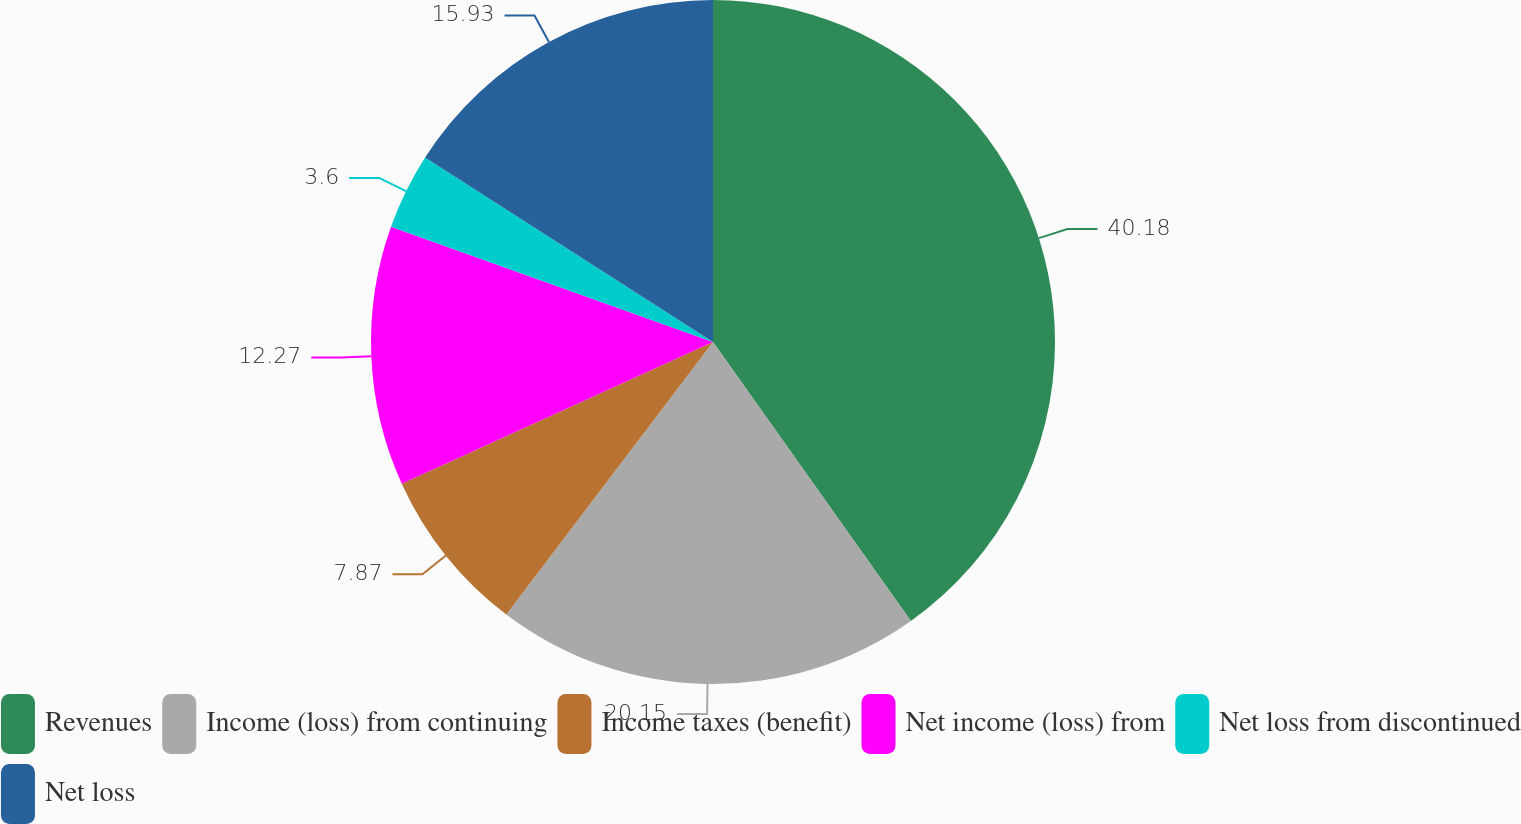<chart> <loc_0><loc_0><loc_500><loc_500><pie_chart><fcel>Revenues<fcel>Income (loss) from continuing<fcel>Income taxes (benefit)<fcel>Net income (loss) from<fcel>Net loss from discontinued<fcel>Net loss<nl><fcel>40.18%<fcel>20.15%<fcel>7.87%<fcel>12.27%<fcel>3.6%<fcel>15.93%<nl></chart> 